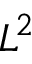<formula> <loc_0><loc_0><loc_500><loc_500>L ^ { 2 }</formula> 